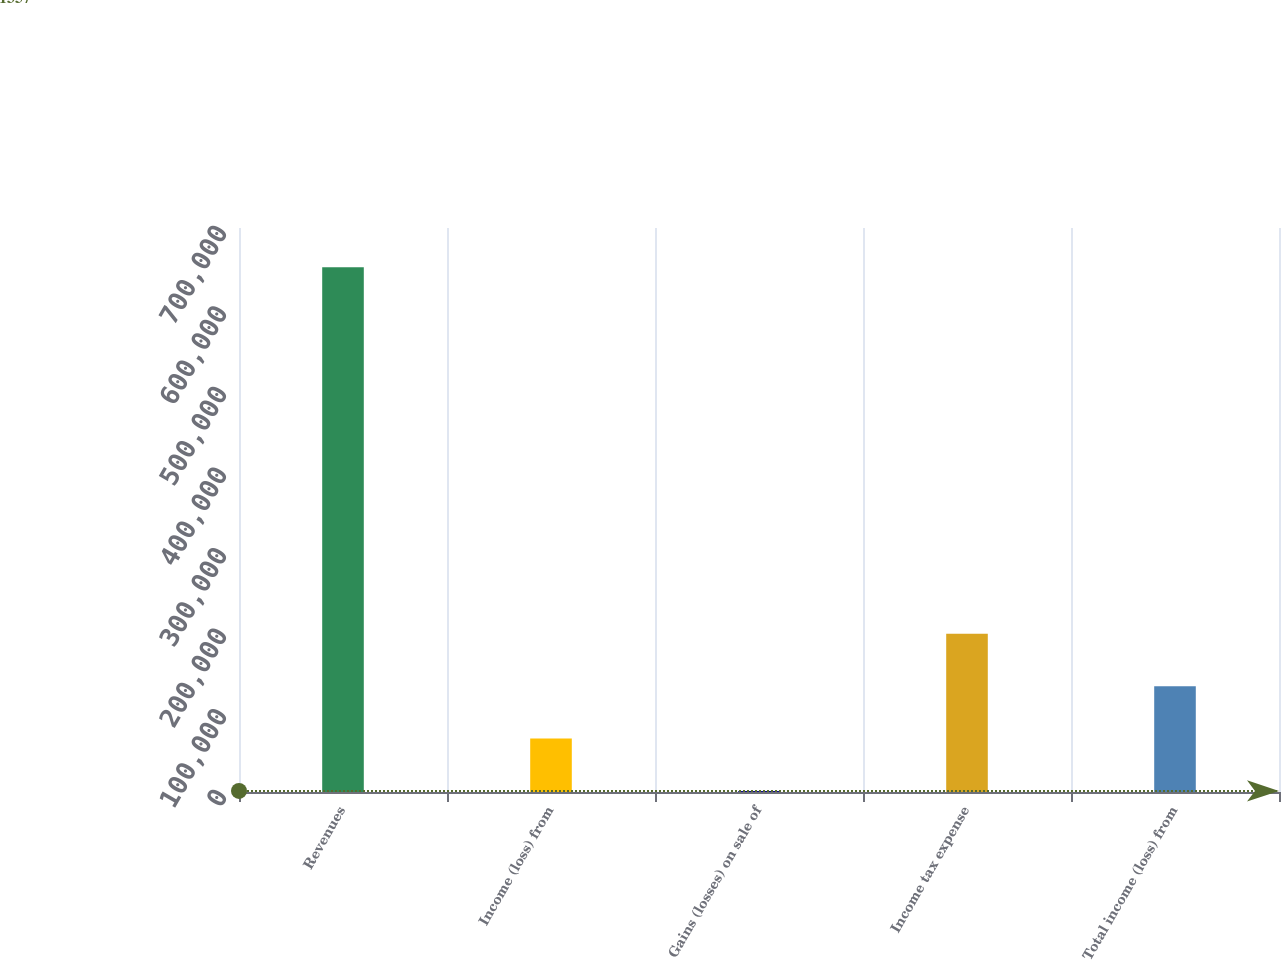<chart> <loc_0><loc_0><loc_500><loc_500><bar_chart><fcel>Revenues<fcel>Income (loss) from<fcel>Gains (losses) on sale of<fcel>Income tax expense<fcel>Total income (loss) from<nl><fcel>651332<fcel>66354.5<fcel>1357<fcel>196350<fcel>131352<nl></chart> 